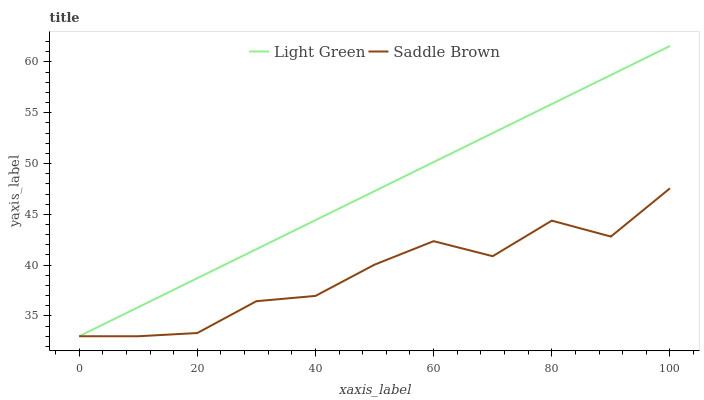Does Saddle Brown have the minimum area under the curve?
Answer yes or no. Yes. Does Light Green have the maximum area under the curve?
Answer yes or no. Yes. Does Light Green have the minimum area under the curve?
Answer yes or no. No. Is Light Green the smoothest?
Answer yes or no. Yes. Is Saddle Brown the roughest?
Answer yes or no. Yes. Is Light Green the roughest?
Answer yes or no. No. Does Saddle Brown have the lowest value?
Answer yes or no. Yes. Does Light Green have the highest value?
Answer yes or no. Yes. Does Light Green intersect Saddle Brown?
Answer yes or no. Yes. Is Light Green less than Saddle Brown?
Answer yes or no. No. Is Light Green greater than Saddle Brown?
Answer yes or no. No. 